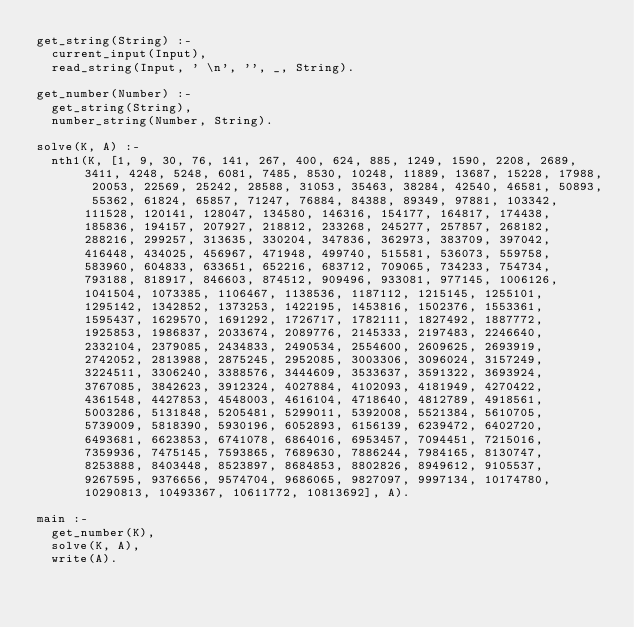<code> <loc_0><loc_0><loc_500><loc_500><_Prolog_>get_string(String) :-
  current_input(Input),
  read_string(Input, ' \n', '', _, String).

get_number(Number) :-
  get_string(String),
  number_string(Number, String).

solve(K, A) :-
  nth1(K, [1, 9, 30, 76, 141, 267, 400, 624, 885, 1249, 1590, 2208, 2689, 3411, 4248, 5248, 6081, 7485, 8530, 10248, 11889, 13687, 15228, 17988, 20053, 22569, 25242, 28588, 31053, 35463, 38284, 42540, 46581, 50893, 55362, 61824, 65857, 71247, 76884, 84388, 89349, 97881, 103342, 111528, 120141, 128047, 134580, 146316, 154177, 164817, 174438, 185836, 194157, 207927, 218812, 233268, 245277, 257857, 268182, 288216, 299257, 313635, 330204, 347836, 362973, 383709, 397042, 416448, 434025, 456967, 471948, 499740, 515581, 536073, 559758, 583960, 604833, 633651, 652216, 683712, 709065, 734233, 754734, 793188, 818917, 846603, 874512, 909496, 933081, 977145, 1006126, 1041504, 1073385, 1106467, 1138536, 1187112, 1215145, 1255101, 1295142, 1342852, 1373253, 1422195, 1453816, 1502376, 1553361, 1595437, 1629570, 1691292, 1726717, 1782111, 1827492, 1887772, 1925853, 1986837, 2033674, 2089776, 2145333, 2197483, 2246640, 2332104, 2379085, 2434833, 2490534, 2554600, 2609625, 2693919, 2742052, 2813988, 2875245, 2952085, 3003306, 3096024, 3157249, 3224511, 3306240, 3388576, 3444609, 3533637, 3591322, 3693924, 3767085, 3842623, 3912324, 4027884, 4102093, 4181949, 4270422, 4361548, 4427853, 4548003, 4616104, 4718640, 4812789, 4918561, 5003286, 5131848, 5205481, 5299011, 5392008, 5521384, 5610705, 5739009, 5818390, 5930196, 6052893, 6156139, 6239472, 6402720, 6493681, 6623853, 6741078, 6864016, 6953457, 7094451, 7215016, 7359936, 7475145, 7593865, 7689630, 7886244, 7984165, 8130747, 8253888, 8403448, 8523897, 8684853, 8802826, 8949612, 9105537, 9267595, 9376656, 9574704, 9686065, 9827097, 9997134, 10174780, 10290813, 10493367, 10611772, 10813692], A).

main :-
  get_number(K),
  solve(K, A),
  write(A).</code> 